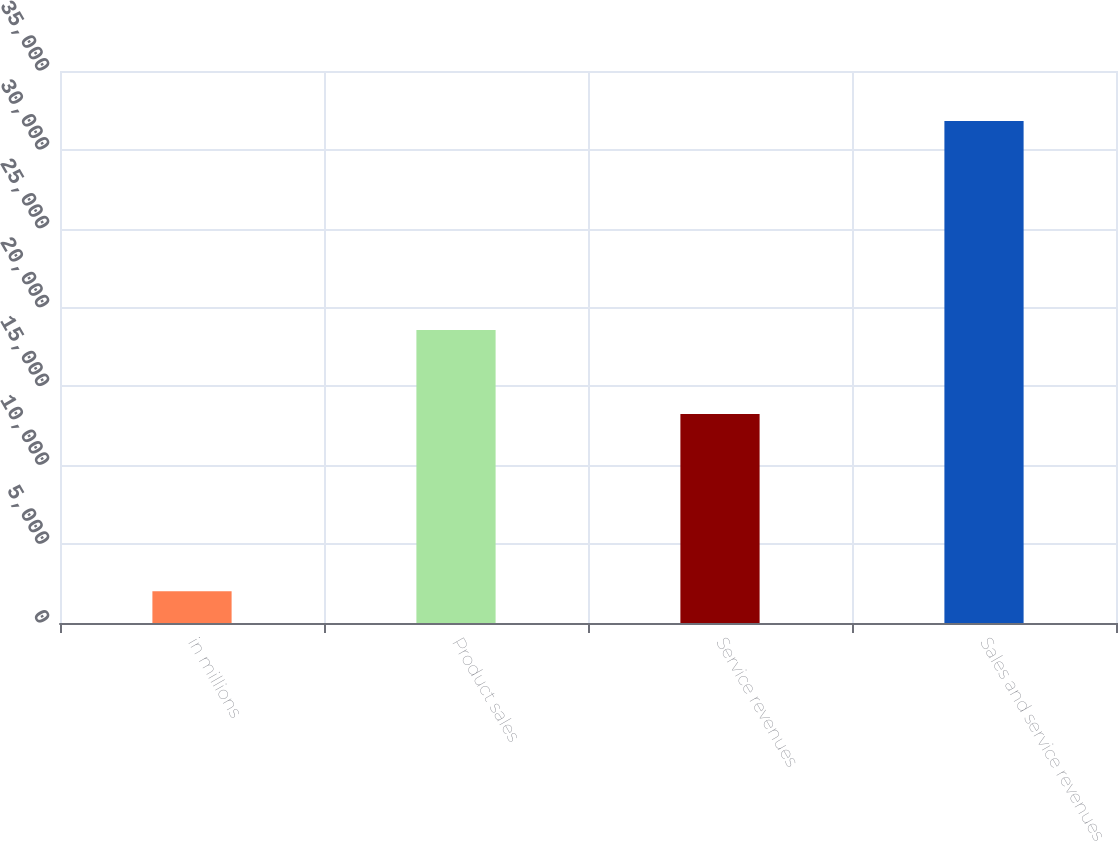Convert chart. <chart><loc_0><loc_0><loc_500><loc_500><bar_chart><fcel>in millions<fcel>Product sales<fcel>Service revenues<fcel>Sales and service revenues<nl><fcel>2007<fcel>18577<fcel>13251<fcel>31828<nl></chart> 